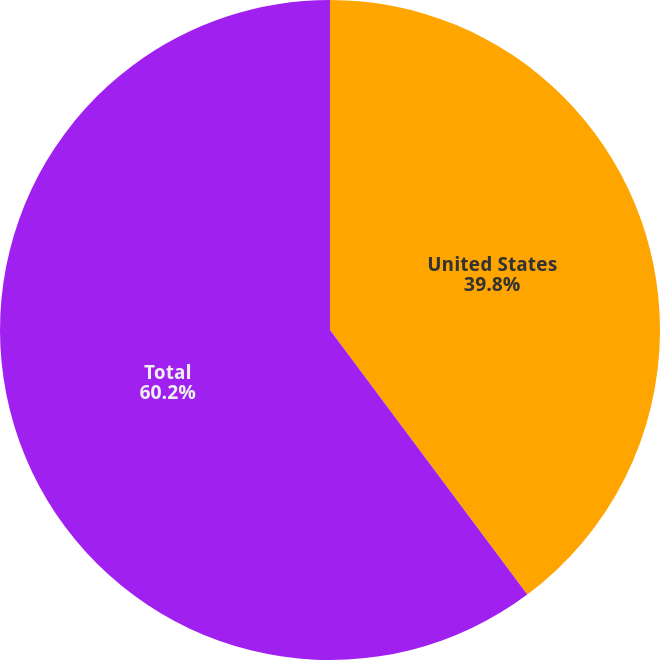<chart> <loc_0><loc_0><loc_500><loc_500><pie_chart><fcel>United States<fcel>Total<nl><fcel>39.8%<fcel>60.2%<nl></chart> 